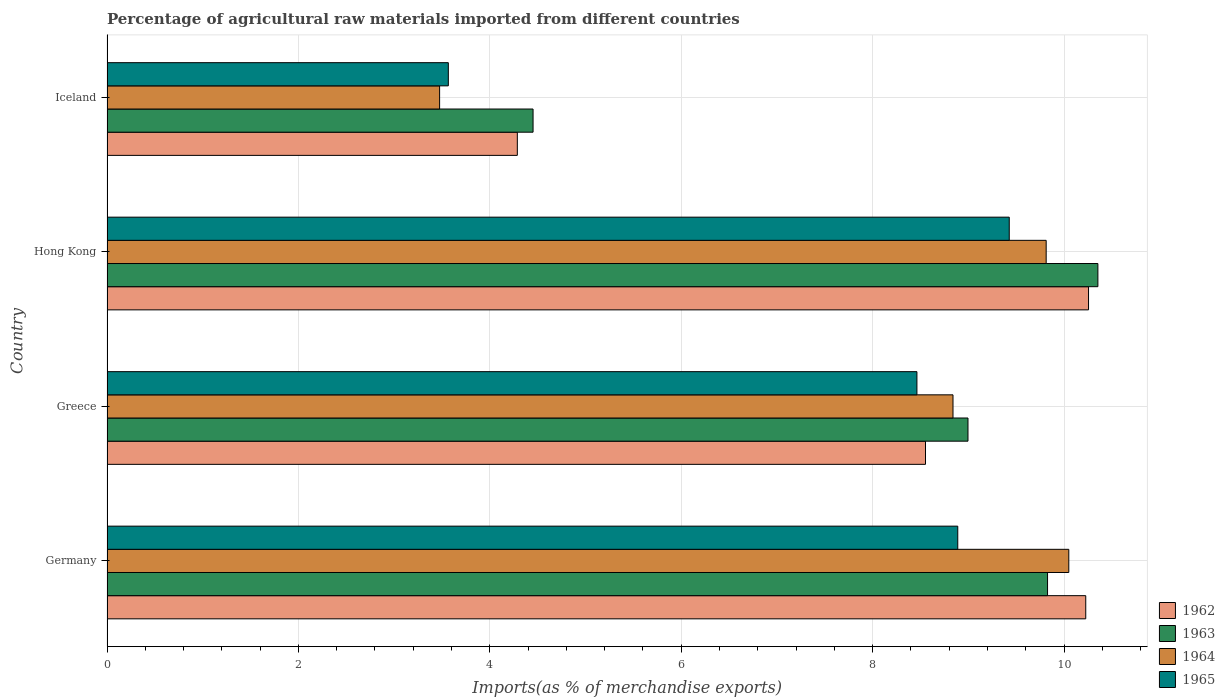Are the number of bars per tick equal to the number of legend labels?
Provide a succinct answer. Yes. Are the number of bars on each tick of the Y-axis equal?
Your answer should be very brief. Yes. How many bars are there on the 1st tick from the top?
Make the answer very short. 4. How many bars are there on the 4th tick from the bottom?
Offer a very short reply. 4. What is the label of the 2nd group of bars from the top?
Make the answer very short. Hong Kong. What is the percentage of imports to different countries in 1963 in Hong Kong?
Offer a terse response. 10.35. Across all countries, what is the maximum percentage of imports to different countries in 1965?
Provide a short and direct response. 9.43. Across all countries, what is the minimum percentage of imports to different countries in 1965?
Your answer should be compact. 3.57. In which country was the percentage of imports to different countries in 1965 maximum?
Offer a terse response. Hong Kong. What is the total percentage of imports to different countries in 1965 in the graph?
Provide a succinct answer. 30.35. What is the difference between the percentage of imports to different countries in 1962 in Germany and that in Iceland?
Provide a succinct answer. 5.94. What is the difference between the percentage of imports to different countries in 1963 in Iceland and the percentage of imports to different countries in 1962 in Germany?
Offer a terse response. -5.77. What is the average percentage of imports to different countries in 1964 per country?
Your response must be concise. 8.04. What is the difference between the percentage of imports to different countries in 1962 and percentage of imports to different countries in 1963 in Germany?
Your answer should be compact. 0.4. What is the ratio of the percentage of imports to different countries in 1964 in Greece to that in Iceland?
Your answer should be very brief. 2.54. Is the percentage of imports to different countries in 1965 in Germany less than that in Hong Kong?
Your response must be concise. Yes. What is the difference between the highest and the second highest percentage of imports to different countries in 1964?
Give a very brief answer. 0.24. What is the difference between the highest and the lowest percentage of imports to different countries in 1964?
Make the answer very short. 6.57. In how many countries, is the percentage of imports to different countries in 1965 greater than the average percentage of imports to different countries in 1965 taken over all countries?
Your answer should be very brief. 3. Is it the case that in every country, the sum of the percentage of imports to different countries in 1963 and percentage of imports to different countries in 1964 is greater than the sum of percentage of imports to different countries in 1965 and percentage of imports to different countries in 1962?
Ensure brevity in your answer.  No. What does the 4th bar from the top in Iceland represents?
Give a very brief answer. 1962. What does the 1st bar from the bottom in Germany represents?
Keep it short and to the point. 1962. Is it the case that in every country, the sum of the percentage of imports to different countries in 1963 and percentage of imports to different countries in 1964 is greater than the percentage of imports to different countries in 1965?
Offer a very short reply. Yes. Are all the bars in the graph horizontal?
Your answer should be compact. Yes. Are the values on the major ticks of X-axis written in scientific E-notation?
Provide a short and direct response. No. How are the legend labels stacked?
Offer a terse response. Vertical. What is the title of the graph?
Your answer should be compact. Percentage of agricultural raw materials imported from different countries. Does "1982" appear as one of the legend labels in the graph?
Give a very brief answer. No. What is the label or title of the X-axis?
Offer a very short reply. Imports(as % of merchandise exports). What is the label or title of the Y-axis?
Provide a short and direct response. Country. What is the Imports(as % of merchandise exports) in 1962 in Germany?
Provide a succinct answer. 10.23. What is the Imports(as % of merchandise exports) in 1963 in Germany?
Offer a very short reply. 9.83. What is the Imports(as % of merchandise exports) in 1964 in Germany?
Give a very brief answer. 10.05. What is the Imports(as % of merchandise exports) of 1965 in Germany?
Offer a terse response. 8.89. What is the Imports(as % of merchandise exports) of 1962 in Greece?
Your answer should be very brief. 8.55. What is the Imports(as % of merchandise exports) of 1963 in Greece?
Ensure brevity in your answer.  9. What is the Imports(as % of merchandise exports) in 1964 in Greece?
Give a very brief answer. 8.84. What is the Imports(as % of merchandise exports) in 1965 in Greece?
Your answer should be compact. 8.46. What is the Imports(as % of merchandise exports) in 1962 in Hong Kong?
Provide a short and direct response. 10.26. What is the Imports(as % of merchandise exports) in 1963 in Hong Kong?
Make the answer very short. 10.35. What is the Imports(as % of merchandise exports) in 1964 in Hong Kong?
Provide a succinct answer. 9.81. What is the Imports(as % of merchandise exports) in 1965 in Hong Kong?
Ensure brevity in your answer.  9.43. What is the Imports(as % of merchandise exports) in 1962 in Iceland?
Offer a very short reply. 4.29. What is the Imports(as % of merchandise exports) in 1963 in Iceland?
Provide a succinct answer. 4.45. What is the Imports(as % of merchandise exports) of 1964 in Iceland?
Ensure brevity in your answer.  3.48. What is the Imports(as % of merchandise exports) in 1965 in Iceland?
Offer a terse response. 3.57. Across all countries, what is the maximum Imports(as % of merchandise exports) in 1962?
Make the answer very short. 10.26. Across all countries, what is the maximum Imports(as % of merchandise exports) of 1963?
Your response must be concise. 10.35. Across all countries, what is the maximum Imports(as % of merchandise exports) of 1964?
Your response must be concise. 10.05. Across all countries, what is the maximum Imports(as % of merchandise exports) in 1965?
Offer a very short reply. 9.43. Across all countries, what is the minimum Imports(as % of merchandise exports) in 1962?
Give a very brief answer. 4.29. Across all countries, what is the minimum Imports(as % of merchandise exports) in 1963?
Your answer should be very brief. 4.45. Across all countries, what is the minimum Imports(as % of merchandise exports) of 1964?
Your response must be concise. 3.48. Across all countries, what is the minimum Imports(as % of merchandise exports) of 1965?
Provide a short and direct response. 3.57. What is the total Imports(as % of merchandise exports) of 1962 in the graph?
Provide a short and direct response. 33.32. What is the total Imports(as % of merchandise exports) of 1963 in the graph?
Keep it short and to the point. 33.63. What is the total Imports(as % of merchandise exports) of 1964 in the graph?
Make the answer very short. 32.18. What is the total Imports(as % of merchandise exports) in 1965 in the graph?
Provide a succinct answer. 30.35. What is the difference between the Imports(as % of merchandise exports) of 1962 in Germany and that in Greece?
Keep it short and to the point. 1.67. What is the difference between the Imports(as % of merchandise exports) in 1963 in Germany and that in Greece?
Give a very brief answer. 0.83. What is the difference between the Imports(as % of merchandise exports) of 1964 in Germany and that in Greece?
Make the answer very short. 1.21. What is the difference between the Imports(as % of merchandise exports) in 1965 in Germany and that in Greece?
Offer a terse response. 0.43. What is the difference between the Imports(as % of merchandise exports) in 1962 in Germany and that in Hong Kong?
Your response must be concise. -0.03. What is the difference between the Imports(as % of merchandise exports) in 1963 in Germany and that in Hong Kong?
Provide a short and direct response. -0.53. What is the difference between the Imports(as % of merchandise exports) in 1964 in Germany and that in Hong Kong?
Your answer should be compact. 0.24. What is the difference between the Imports(as % of merchandise exports) of 1965 in Germany and that in Hong Kong?
Ensure brevity in your answer.  -0.54. What is the difference between the Imports(as % of merchandise exports) of 1962 in Germany and that in Iceland?
Make the answer very short. 5.94. What is the difference between the Imports(as % of merchandise exports) of 1963 in Germany and that in Iceland?
Make the answer very short. 5.38. What is the difference between the Imports(as % of merchandise exports) of 1964 in Germany and that in Iceland?
Offer a very short reply. 6.57. What is the difference between the Imports(as % of merchandise exports) of 1965 in Germany and that in Iceland?
Your answer should be very brief. 5.32. What is the difference between the Imports(as % of merchandise exports) in 1962 in Greece and that in Hong Kong?
Give a very brief answer. -1.7. What is the difference between the Imports(as % of merchandise exports) in 1963 in Greece and that in Hong Kong?
Your answer should be very brief. -1.36. What is the difference between the Imports(as % of merchandise exports) of 1964 in Greece and that in Hong Kong?
Ensure brevity in your answer.  -0.97. What is the difference between the Imports(as % of merchandise exports) of 1965 in Greece and that in Hong Kong?
Give a very brief answer. -0.96. What is the difference between the Imports(as % of merchandise exports) of 1962 in Greece and that in Iceland?
Keep it short and to the point. 4.26. What is the difference between the Imports(as % of merchandise exports) of 1963 in Greece and that in Iceland?
Your response must be concise. 4.54. What is the difference between the Imports(as % of merchandise exports) in 1964 in Greece and that in Iceland?
Offer a terse response. 5.36. What is the difference between the Imports(as % of merchandise exports) in 1965 in Greece and that in Iceland?
Give a very brief answer. 4.9. What is the difference between the Imports(as % of merchandise exports) of 1962 in Hong Kong and that in Iceland?
Make the answer very short. 5.97. What is the difference between the Imports(as % of merchandise exports) in 1963 in Hong Kong and that in Iceland?
Give a very brief answer. 5.9. What is the difference between the Imports(as % of merchandise exports) in 1964 in Hong Kong and that in Iceland?
Make the answer very short. 6.34. What is the difference between the Imports(as % of merchandise exports) in 1965 in Hong Kong and that in Iceland?
Give a very brief answer. 5.86. What is the difference between the Imports(as % of merchandise exports) of 1962 in Germany and the Imports(as % of merchandise exports) of 1963 in Greece?
Make the answer very short. 1.23. What is the difference between the Imports(as % of merchandise exports) in 1962 in Germany and the Imports(as % of merchandise exports) in 1964 in Greece?
Provide a short and direct response. 1.39. What is the difference between the Imports(as % of merchandise exports) of 1962 in Germany and the Imports(as % of merchandise exports) of 1965 in Greece?
Your answer should be very brief. 1.76. What is the difference between the Imports(as % of merchandise exports) in 1963 in Germany and the Imports(as % of merchandise exports) in 1965 in Greece?
Ensure brevity in your answer.  1.36. What is the difference between the Imports(as % of merchandise exports) of 1964 in Germany and the Imports(as % of merchandise exports) of 1965 in Greece?
Give a very brief answer. 1.59. What is the difference between the Imports(as % of merchandise exports) in 1962 in Germany and the Imports(as % of merchandise exports) in 1963 in Hong Kong?
Offer a very short reply. -0.13. What is the difference between the Imports(as % of merchandise exports) of 1962 in Germany and the Imports(as % of merchandise exports) of 1964 in Hong Kong?
Keep it short and to the point. 0.41. What is the difference between the Imports(as % of merchandise exports) of 1962 in Germany and the Imports(as % of merchandise exports) of 1965 in Hong Kong?
Provide a succinct answer. 0.8. What is the difference between the Imports(as % of merchandise exports) of 1963 in Germany and the Imports(as % of merchandise exports) of 1964 in Hong Kong?
Your answer should be compact. 0.01. What is the difference between the Imports(as % of merchandise exports) of 1963 in Germany and the Imports(as % of merchandise exports) of 1965 in Hong Kong?
Offer a very short reply. 0.4. What is the difference between the Imports(as % of merchandise exports) of 1964 in Germany and the Imports(as % of merchandise exports) of 1965 in Hong Kong?
Provide a short and direct response. 0.62. What is the difference between the Imports(as % of merchandise exports) of 1962 in Germany and the Imports(as % of merchandise exports) of 1963 in Iceland?
Give a very brief answer. 5.77. What is the difference between the Imports(as % of merchandise exports) of 1962 in Germany and the Imports(as % of merchandise exports) of 1964 in Iceland?
Keep it short and to the point. 6.75. What is the difference between the Imports(as % of merchandise exports) of 1962 in Germany and the Imports(as % of merchandise exports) of 1965 in Iceland?
Offer a very short reply. 6.66. What is the difference between the Imports(as % of merchandise exports) of 1963 in Germany and the Imports(as % of merchandise exports) of 1964 in Iceland?
Make the answer very short. 6.35. What is the difference between the Imports(as % of merchandise exports) in 1963 in Germany and the Imports(as % of merchandise exports) in 1965 in Iceland?
Provide a succinct answer. 6.26. What is the difference between the Imports(as % of merchandise exports) of 1964 in Germany and the Imports(as % of merchandise exports) of 1965 in Iceland?
Keep it short and to the point. 6.48. What is the difference between the Imports(as % of merchandise exports) of 1962 in Greece and the Imports(as % of merchandise exports) of 1963 in Hong Kong?
Ensure brevity in your answer.  -1.8. What is the difference between the Imports(as % of merchandise exports) of 1962 in Greece and the Imports(as % of merchandise exports) of 1964 in Hong Kong?
Provide a succinct answer. -1.26. What is the difference between the Imports(as % of merchandise exports) of 1962 in Greece and the Imports(as % of merchandise exports) of 1965 in Hong Kong?
Give a very brief answer. -0.88. What is the difference between the Imports(as % of merchandise exports) in 1963 in Greece and the Imports(as % of merchandise exports) in 1964 in Hong Kong?
Give a very brief answer. -0.82. What is the difference between the Imports(as % of merchandise exports) in 1963 in Greece and the Imports(as % of merchandise exports) in 1965 in Hong Kong?
Your answer should be very brief. -0.43. What is the difference between the Imports(as % of merchandise exports) in 1964 in Greece and the Imports(as % of merchandise exports) in 1965 in Hong Kong?
Your answer should be very brief. -0.59. What is the difference between the Imports(as % of merchandise exports) in 1962 in Greece and the Imports(as % of merchandise exports) in 1963 in Iceland?
Offer a very short reply. 4.1. What is the difference between the Imports(as % of merchandise exports) in 1962 in Greece and the Imports(as % of merchandise exports) in 1964 in Iceland?
Keep it short and to the point. 5.08. What is the difference between the Imports(as % of merchandise exports) of 1962 in Greece and the Imports(as % of merchandise exports) of 1965 in Iceland?
Offer a terse response. 4.99. What is the difference between the Imports(as % of merchandise exports) of 1963 in Greece and the Imports(as % of merchandise exports) of 1964 in Iceland?
Your response must be concise. 5.52. What is the difference between the Imports(as % of merchandise exports) in 1963 in Greece and the Imports(as % of merchandise exports) in 1965 in Iceland?
Keep it short and to the point. 5.43. What is the difference between the Imports(as % of merchandise exports) in 1964 in Greece and the Imports(as % of merchandise exports) in 1965 in Iceland?
Provide a succinct answer. 5.27. What is the difference between the Imports(as % of merchandise exports) of 1962 in Hong Kong and the Imports(as % of merchandise exports) of 1963 in Iceland?
Ensure brevity in your answer.  5.8. What is the difference between the Imports(as % of merchandise exports) of 1962 in Hong Kong and the Imports(as % of merchandise exports) of 1964 in Iceland?
Make the answer very short. 6.78. What is the difference between the Imports(as % of merchandise exports) in 1962 in Hong Kong and the Imports(as % of merchandise exports) in 1965 in Iceland?
Provide a short and direct response. 6.69. What is the difference between the Imports(as % of merchandise exports) in 1963 in Hong Kong and the Imports(as % of merchandise exports) in 1964 in Iceland?
Offer a terse response. 6.88. What is the difference between the Imports(as % of merchandise exports) in 1963 in Hong Kong and the Imports(as % of merchandise exports) in 1965 in Iceland?
Offer a very short reply. 6.79. What is the difference between the Imports(as % of merchandise exports) of 1964 in Hong Kong and the Imports(as % of merchandise exports) of 1965 in Iceland?
Keep it short and to the point. 6.25. What is the average Imports(as % of merchandise exports) of 1962 per country?
Offer a very short reply. 8.33. What is the average Imports(as % of merchandise exports) of 1963 per country?
Offer a very short reply. 8.41. What is the average Imports(as % of merchandise exports) of 1964 per country?
Offer a very short reply. 8.04. What is the average Imports(as % of merchandise exports) in 1965 per country?
Ensure brevity in your answer.  7.59. What is the difference between the Imports(as % of merchandise exports) in 1962 and Imports(as % of merchandise exports) in 1963 in Germany?
Provide a short and direct response. 0.4. What is the difference between the Imports(as % of merchandise exports) in 1962 and Imports(as % of merchandise exports) in 1964 in Germany?
Offer a terse response. 0.18. What is the difference between the Imports(as % of merchandise exports) in 1962 and Imports(as % of merchandise exports) in 1965 in Germany?
Offer a very short reply. 1.34. What is the difference between the Imports(as % of merchandise exports) of 1963 and Imports(as % of merchandise exports) of 1964 in Germany?
Your response must be concise. -0.22. What is the difference between the Imports(as % of merchandise exports) in 1963 and Imports(as % of merchandise exports) in 1965 in Germany?
Your response must be concise. 0.94. What is the difference between the Imports(as % of merchandise exports) of 1964 and Imports(as % of merchandise exports) of 1965 in Germany?
Make the answer very short. 1.16. What is the difference between the Imports(as % of merchandise exports) in 1962 and Imports(as % of merchandise exports) in 1963 in Greece?
Provide a succinct answer. -0.44. What is the difference between the Imports(as % of merchandise exports) in 1962 and Imports(as % of merchandise exports) in 1964 in Greece?
Ensure brevity in your answer.  -0.29. What is the difference between the Imports(as % of merchandise exports) of 1962 and Imports(as % of merchandise exports) of 1965 in Greece?
Your answer should be very brief. 0.09. What is the difference between the Imports(as % of merchandise exports) in 1963 and Imports(as % of merchandise exports) in 1964 in Greece?
Offer a very short reply. 0.16. What is the difference between the Imports(as % of merchandise exports) of 1963 and Imports(as % of merchandise exports) of 1965 in Greece?
Provide a short and direct response. 0.53. What is the difference between the Imports(as % of merchandise exports) of 1964 and Imports(as % of merchandise exports) of 1965 in Greece?
Give a very brief answer. 0.38. What is the difference between the Imports(as % of merchandise exports) of 1962 and Imports(as % of merchandise exports) of 1963 in Hong Kong?
Make the answer very short. -0.1. What is the difference between the Imports(as % of merchandise exports) in 1962 and Imports(as % of merchandise exports) in 1964 in Hong Kong?
Provide a succinct answer. 0.44. What is the difference between the Imports(as % of merchandise exports) of 1962 and Imports(as % of merchandise exports) of 1965 in Hong Kong?
Offer a very short reply. 0.83. What is the difference between the Imports(as % of merchandise exports) in 1963 and Imports(as % of merchandise exports) in 1964 in Hong Kong?
Provide a short and direct response. 0.54. What is the difference between the Imports(as % of merchandise exports) of 1963 and Imports(as % of merchandise exports) of 1965 in Hong Kong?
Keep it short and to the point. 0.93. What is the difference between the Imports(as % of merchandise exports) in 1964 and Imports(as % of merchandise exports) in 1965 in Hong Kong?
Keep it short and to the point. 0.39. What is the difference between the Imports(as % of merchandise exports) in 1962 and Imports(as % of merchandise exports) in 1963 in Iceland?
Provide a short and direct response. -0.16. What is the difference between the Imports(as % of merchandise exports) of 1962 and Imports(as % of merchandise exports) of 1964 in Iceland?
Your response must be concise. 0.81. What is the difference between the Imports(as % of merchandise exports) in 1962 and Imports(as % of merchandise exports) in 1965 in Iceland?
Your response must be concise. 0.72. What is the difference between the Imports(as % of merchandise exports) of 1963 and Imports(as % of merchandise exports) of 1964 in Iceland?
Keep it short and to the point. 0.98. What is the difference between the Imports(as % of merchandise exports) of 1963 and Imports(as % of merchandise exports) of 1965 in Iceland?
Keep it short and to the point. 0.89. What is the difference between the Imports(as % of merchandise exports) in 1964 and Imports(as % of merchandise exports) in 1965 in Iceland?
Offer a very short reply. -0.09. What is the ratio of the Imports(as % of merchandise exports) of 1962 in Germany to that in Greece?
Your answer should be very brief. 1.2. What is the ratio of the Imports(as % of merchandise exports) of 1963 in Germany to that in Greece?
Make the answer very short. 1.09. What is the ratio of the Imports(as % of merchandise exports) in 1964 in Germany to that in Greece?
Ensure brevity in your answer.  1.14. What is the ratio of the Imports(as % of merchandise exports) in 1965 in Germany to that in Greece?
Give a very brief answer. 1.05. What is the ratio of the Imports(as % of merchandise exports) of 1962 in Germany to that in Hong Kong?
Your response must be concise. 1. What is the ratio of the Imports(as % of merchandise exports) of 1963 in Germany to that in Hong Kong?
Your answer should be very brief. 0.95. What is the ratio of the Imports(as % of merchandise exports) of 1964 in Germany to that in Hong Kong?
Offer a very short reply. 1.02. What is the ratio of the Imports(as % of merchandise exports) of 1965 in Germany to that in Hong Kong?
Offer a very short reply. 0.94. What is the ratio of the Imports(as % of merchandise exports) of 1962 in Germany to that in Iceland?
Offer a very short reply. 2.39. What is the ratio of the Imports(as % of merchandise exports) in 1963 in Germany to that in Iceland?
Offer a terse response. 2.21. What is the ratio of the Imports(as % of merchandise exports) in 1964 in Germany to that in Iceland?
Provide a short and direct response. 2.89. What is the ratio of the Imports(as % of merchandise exports) in 1965 in Germany to that in Iceland?
Provide a succinct answer. 2.49. What is the ratio of the Imports(as % of merchandise exports) in 1962 in Greece to that in Hong Kong?
Offer a very short reply. 0.83. What is the ratio of the Imports(as % of merchandise exports) of 1963 in Greece to that in Hong Kong?
Offer a very short reply. 0.87. What is the ratio of the Imports(as % of merchandise exports) in 1964 in Greece to that in Hong Kong?
Provide a short and direct response. 0.9. What is the ratio of the Imports(as % of merchandise exports) of 1965 in Greece to that in Hong Kong?
Offer a terse response. 0.9. What is the ratio of the Imports(as % of merchandise exports) in 1962 in Greece to that in Iceland?
Make the answer very short. 1.99. What is the ratio of the Imports(as % of merchandise exports) in 1963 in Greece to that in Iceland?
Make the answer very short. 2.02. What is the ratio of the Imports(as % of merchandise exports) in 1964 in Greece to that in Iceland?
Provide a short and direct response. 2.54. What is the ratio of the Imports(as % of merchandise exports) in 1965 in Greece to that in Iceland?
Make the answer very short. 2.37. What is the ratio of the Imports(as % of merchandise exports) in 1962 in Hong Kong to that in Iceland?
Your response must be concise. 2.39. What is the ratio of the Imports(as % of merchandise exports) of 1963 in Hong Kong to that in Iceland?
Provide a succinct answer. 2.33. What is the ratio of the Imports(as % of merchandise exports) in 1964 in Hong Kong to that in Iceland?
Provide a short and direct response. 2.82. What is the ratio of the Imports(as % of merchandise exports) of 1965 in Hong Kong to that in Iceland?
Your response must be concise. 2.64. What is the difference between the highest and the second highest Imports(as % of merchandise exports) of 1962?
Ensure brevity in your answer.  0.03. What is the difference between the highest and the second highest Imports(as % of merchandise exports) of 1963?
Your answer should be very brief. 0.53. What is the difference between the highest and the second highest Imports(as % of merchandise exports) of 1964?
Keep it short and to the point. 0.24. What is the difference between the highest and the second highest Imports(as % of merchandise exports) of 1965?
Provide a succinct answer. 0.54. What is the difference between the highest and the lowest Imports(as % of merchandise exports) in 1962?
Offer a very short reply. 5.97. What is the difference between the highest and the lowest Imports(as % of merchandise exports) of 1963?
Ensure brevity in your answer.  5.9. What is the difference between the highest and the lowest Imports(as % of merchandise exports) of 1964?
Provide a succinct answer. 6.57. What is the difference between the highest and the lowest Imports(as % of merchandise exports) in 1965?
Make the answer very short. 5.86. 